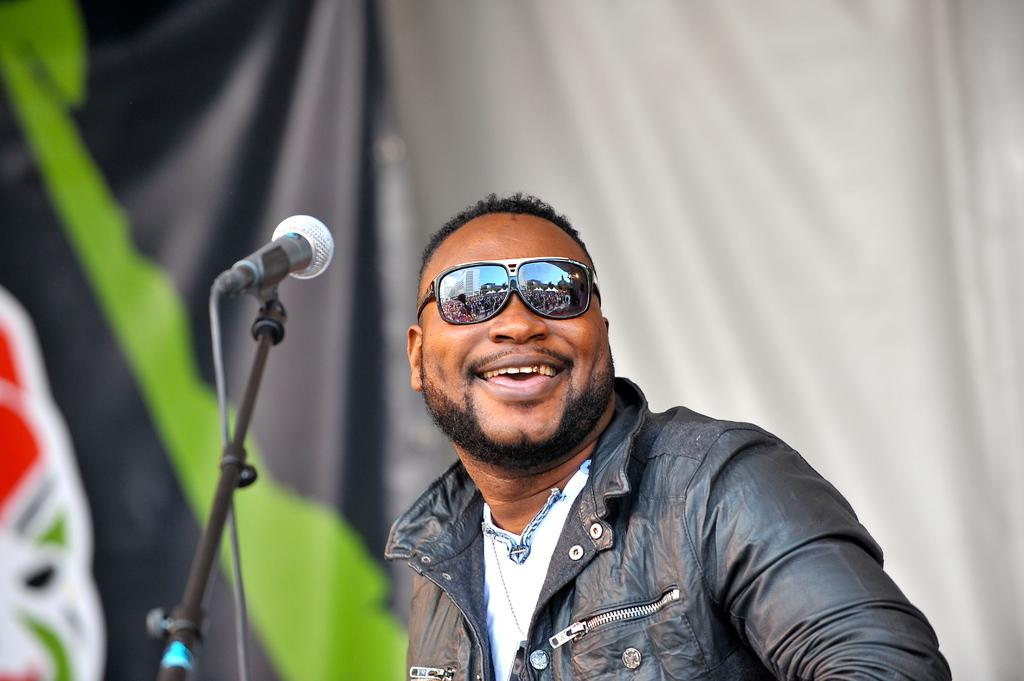Who is present in the image? There is a man in the image. What is the man doing in the image? The man is smiling in the image. What accessory is the man wearing? The man is wearing spectacles in the image. What object is in front of the man? There is a microphone in front of the man in the image. What type of soap is the man using to wash his hands in the image? There is no soap or hand-washing activity present in the image. 